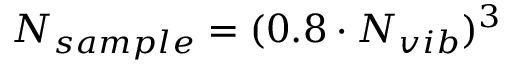Convert formula to latex. <formula><loc_0><loc_0><loc_500><loc_500>N _ { s a m p l e } = ( 0 . 8 \cdot N _ { v i b } ) ^ { 3 }</formula> 